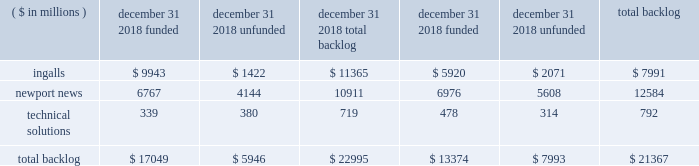December 2016 acquisition of camber and higher volumes in fleet support and oil and gas services , partially offset by lower nuclear and environmental volumes due to the resolution in 2016 of outstanding contract changes on a nuclear and environmental commercial contract .
Segment operating income 2018 - operating income in the technical solutions segment for the year ended december 31 , 2018 , was $ 32 million , compared to operating income of $ 21 million in 2017 .
The increase was primarily due to an allowance for accounts receivable in 2017 on a nuclear and environmental commercial contract and higher income from operating investments at our nuclear and environmental joint ventures , partially offset by one time employee bonus payments in 2018 related to the tax act and lower performance in fleet support services .
2017 - operating income in the technical solutions segment for the year ended december 31 , 2017 , was $ 21 million , compared to operating income of $ 8 million in 2016 .
The increase was primarily due to improved performance in oil and gas services and higher volume in mdis services following the december 2016 acquisition of camber , partially offset by the establishment of an allowance for accounts receivable on a nuclear and environmental commercial contract in 2017 and the resolution in 2016 of outstanding contract changes on a nuclear and environmental commercial contract .
Backlog total backlog as of december 31 , 2018 , was approximately $ 23 billion .
Total backlog includes both funded backlog ( firm orders for which funding is contractually obligated by the customer ) and unfunded backlog ( firm orders for which funding is not currently contractually obligated by the customer ) .
Backlog excludes unexercised contract options and unfunded idiq orders .
For contracts having no stated contract values , backlog includes only the amounts committed by the customer .
The table presents funded and unfunded backlog by segment as of december 31 , 2018 and 2017: .
We expect approximately 30% ( 30 % ) of the $ 23 billion total backlog as of december 31 , 2018 , to be converted into sales in 2019 .
U.s .
Government orders comprised substantially all of the backlog as of december 31 , 2018 and 2017 .
Awards 2018 - the value of new contract awards during the year ended december 31 , 2018 , was approximately $ 9.8 billion .
Significant new awards during the period included contracts for the construction of three arleigh burke class ( ddg 51 ) destroyers , for the detail design and construction of richard m .
Mccool jr .
( lpd 29 ) , for procurement of long-lead-time material for enterprise ( cvn 80 ) , and for the construction of nsc 10 ( unnamed ) and nsc 11 ( unnamed ) .
In addition , we received awards in 2019 valued at $ 15.2 billion for detail design and construction of the gerald r .
Ford class ( cvn 78 ) aircraft carriers enterprise ( cvn 80 ) and cvn 81 ( unnamed ) .
2017 - the value of new contract awards during the year ended december 31 , 2017 , was approximately $ 8.1 billion .
Significant new awards during this period included the detailed design and construction contract for bougainville ( lha 8 ) and the execution contract for the rcoh of uss george washington ( cvn 73 ) . .
What portion of total backlog is related to ingalls segment? 
Computations: (7991 / 21367)
Answer: 0.37399. December 2016 acquisition of camber and higher volumes in fleet support and oil and gas services , partially offset by lower nuclear and environmental volumes due to the resolution in 2016 of outstanding contract changes on a nuclear and environmental commercial contract .
Segment operating income 2018 - operating income in the technical solutions segment for the year ended december 31 , 2018 , was $ 32 million , compared to operating income of $ 21 million in 2017 .
The increase was primarily due to an allowance for accounts receivable in 2017 on a nuclear and environmental commercial contract and higher income from operating investments at our nuclear and environmental joint ventures , partially offset by one time employee bonus payments in 2018 related to the tax act and lower performance in fleet support services .
2017 - operating income in the technical solutions segment for the year ended december 31 , 2017 , was $ 21 million , compared to operating income of $ 8 million in 2016 .
The increase was primarily due to improved performance in oil and gas services and higher volume in mdis services following the december 2016 acquisition of camber , partially offset by the establishment of an allowance for accounts receivable on a nuclear and environmental commercial contract in 2017 and the resolution in 2016 of outstanding contract changes on a nuclear and environmental commercial contract .
Backlog total backlog as of december 31 , 2018 , was approximately $ 23 billion .
Total backlog includes both funded backlog ( firm orders for which funding is contractually obligated by the customer ) and unfunded backlog ( firm orders for which funding is not currently contractually obligated by the customer ) .
Backlog excludes unexercised contract options and unfunded idiq orders .
For contracts having no stated contract values , backlog includes only the amounts committed by the customer .
The table presents funded and unfunded backlog by segment as of december 31 , 2018 and 2017: .
We expect approximately 30% ( 30 % ) of the $ 23 billion total backlog as of december 31 , 2018 , to be converted into sales in 2019 .
U.s .
Government orders comprised substantially all of the backlog as of december 31 , 2018 and 2017 .
Awards 2018 - the value of new contract awards during the year ended december 31 , 2018 , was approximately $ 9.8 billion .
Significant new awards during the period included contracts for the construction of three arleigh burke class ( ddg 51 ) destroyers , for the detail design and construction of richard m .
Mccool jr .
( lpd 29 ) , for procurement of long-lead-time material for enterprise ( cvn 80 ) , and for the construction of nsc 10 ( unnamed ) and nsc 11 ( unnamed ) .
In addition , we received awards in 2019 valued at $ 15.2 billion for detail design and construction of the gerald r .
Ford class ( cvn 78 ) aircraft carriers enterprise ( cvn 80 ) and cvn 81 ( unnamed ) .
2017 - the value of new contract awards during the year ended december 31 , 2017 , was approximately $ 8.1 billion .
Significant new awards during this period included the detailed design and construction contract for bougainville ( lha 8 ) and the execution contract for the rcoh of uss george washington ( cvn 73 ) . .
What is the growth rate of operating income for technical solutions segment from 2017 to 2018? 
Computations: ((32 - 21) / 21)
Answer: 0.52381. December 2016 acquisition of camber and higher volumes in fleet support and oil and gas services , partially offset by lower nuclear and environmental volumes due to the resolution in 2016 of outstanding contract changes on a nuclear and environmental commercial contract .
Segment operating income 2018 - operating income in the technical solutions segment for the year ended december 31 , 2018 , was $ 32 million , compared to operating income of $ 21 million in 2017 .
The increase was primarily due to an allowance for accounts receivable in 2017 on a nuclear and environmental commercial contract and higher income from operating investments at our nuclear and environmental joint ventures , partially offset by one time employee bonus payments in 2018 related to the tax act and lower performance in fleet support services .
2017 - operating income in the technical solutions segment for the year ended december 31 , 2017 , was $ 21 million , compared to operating income of $ 8 million in 2016 .
The increase was primarily due to improved performance in oil and gas services and higher volume in mdis services following the december 2016 acquisition of camber , partially offset by the establishment of an allowance for accounts receivable on a nuclear and environmental commercial contract in 2017 and the resolution in 2016 of outstanding contract changes on a nuclear and environmental commercial contract .
Backlog total backlog as of december 31 , 2018 , was approximately $ 23 billion .
Total backlog includes both funded backlog ( firm orders for which funding is contractually obligated by the customer ) and unfunded backlog ( firm orders for which funding is not currently contractually obligated by the customer ) .
Backlog excludes unexercised contract options and unfunded idiq orders .
For contracts having no stated contract values , backlog includes only the amounts committed by the customer .
The table presents funded and unfunded backlog by segment as of december 31 , 2018 and 2017: .
We expect approximately 30% ( 30 % ) of the $ 23 billion total backlog as of december 31 , 2018 , to be converted into sales in 2019 .
U.s .
Government orders comprised substantially all of the backlog as of december 31 , 2018 and 2017 .
Awards 2018 - the value of new contract awards during the year ended december 31 , 2018 , was approximately $ 9.8 billion .
Significant new awards during the period included contracts for the construction of three arleigh burke class ( ddg 51 ) destroyers , for the detail design and construction of richard m .
Mccool jr .
( lpd 29 ) , for procurement of long-lead-time material for enterprise ( cvn 80 ) , and for the construction of nsc 10 ( unnamed ) and nsc 11 ( unnamed ) .
In addition , we received awards in 2019 valued at $ 15.2 billion for detail design and construction of the gerald r .
Ford class ( cvn 78 ) aircraft carriers enterprise ( cvn 80 ) and cvn 81 ( unnamed ) .
2017 - the value of new contract awards during the year ended december 31 , 2017 , was approximately $ 8.1 billion .
Significant new awards during this period included the detailed design and construction contract for bougainville ( lha 8 ) and the execution contract for the rcoh of uss george washington ( cvn 73 ) . .
What was the percentage increase in the operating income from 2016 to 2017? 
Rationale: the percent of the growth is the increase divided by the original amount
Computations: ((21 - 8) / 8)
Answer: 1.625. 